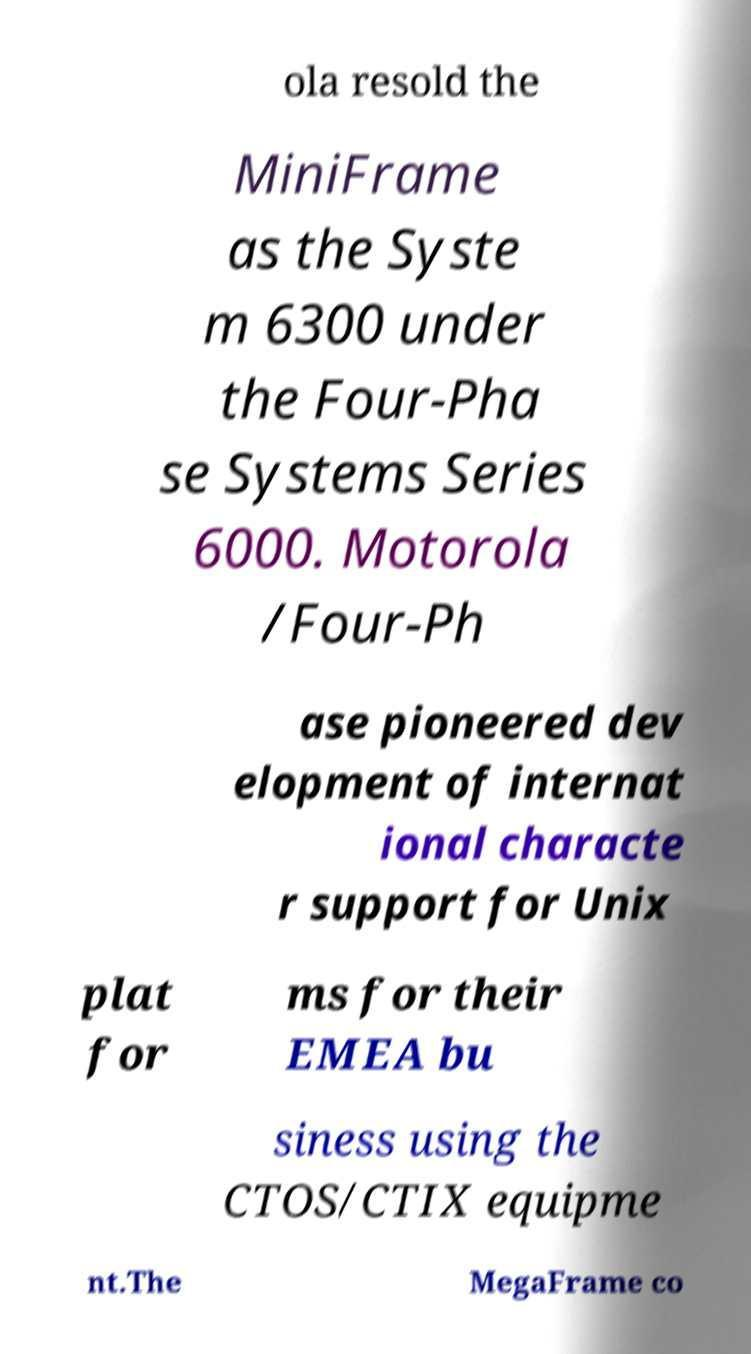Could you extract and type out the text from this image? ola resold the MiniFrame as the Syste m 6300 under the Four-Pha se Systems Series 6000. Motorola /Four-Ph ase pioneered dev elopment of internat ional characte r support for Unix plat for ms for their EMEA bu siness using the CTOS/CTIX equipme nt.The MegaFrame co 